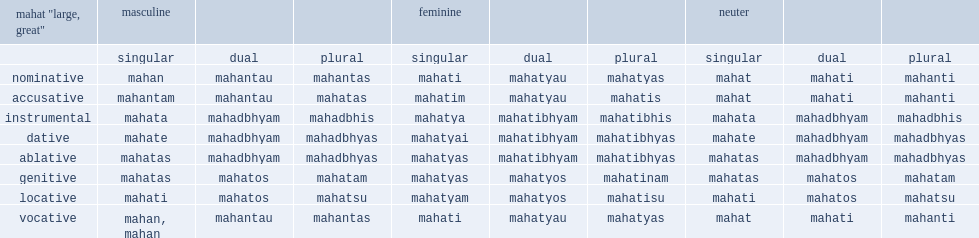What is the singular form of the masculine? Mahan. 